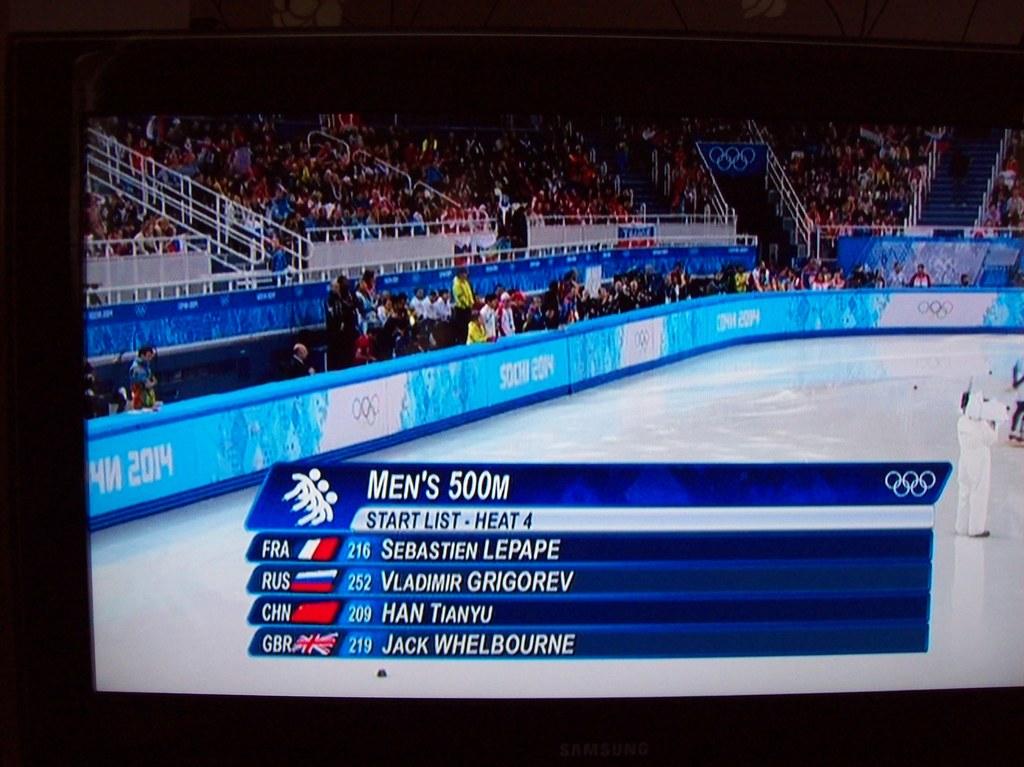Who is the athlete from china?
Provide a short and direct response. Han tianyu. Who finished first?
Your answer should be very brief. Sebastien lepape. 